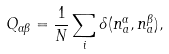Convert formula to latex. <formula><loc_0><loc_0><loc_500><loc_500>Q _ { \alpha \beta } = \frac { 1 } { N } \sum _ { i } \delta ( n _ { a } ^ { \alpha } , n _ { a } ^ { \beta } ) ,</formula> 